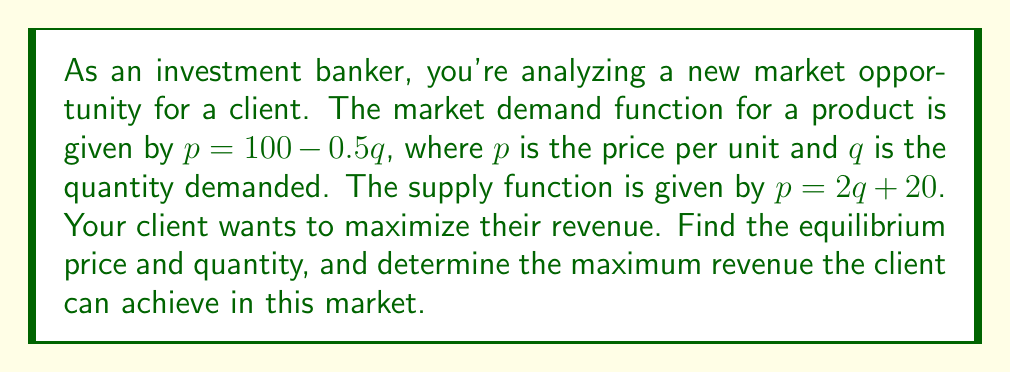Can you solve this math problem? Let's approach this step-by-step:

1) First, we need to find the equilibrium price and quantity. At equilibrium, supply equals demand:

   $100 - 0.5q = 2q + 20$

2) Solve this equation:
   
   $80 = 2.5q$
   $q = 32$

3) Now we can find the equilibrium price by substituting $q = 32$ into either the demand or supply equation:

   $p = 100 - 0.5(32) = 84$

   So, the equilibrium price is $84 and the equilibrium quantity is 32.

4) To find the maximum revenue, we need to use the demand function to express revenue in terms of quantity:

   Revenue $R = pq = (100 - 0.5q)q = 100q - 0.5q^2$

5) This is a quadratic function. To find the maximum, we differentiate and set to zero:

   $\frac{dR}{dq} = 100 - q = 0$
   $q = 100$

6) The second derivative is negative ($-1$), confirming this is a maximum.

7) To find the maximum revenue, we substitute $q = 100$ into the revenue function:

   $R = 100(100) - 0.5(100)^2 = 10000 - 5000 = 5000$

Therefore, the maximum revenue is $5000.

8) Note that this maximum revenue occurs at a different point than the equilibrium. At $q = 100$, the price would be:

   $p = 100 - 0.5(100) = 50$

This analysis shows that while the market equilibrium occurs at a price of $84 and quantity of 32, the maximum revenue for a single firm would occur at a price of $50 and quantity of 100, assuming they could capture the entire market at that point.
Answer: The equilibrium price is $84 and the equilibrium quantity is 32. The maximum revenue achievable is $5000, which occurs at a price of $50 and quantity of 100. 